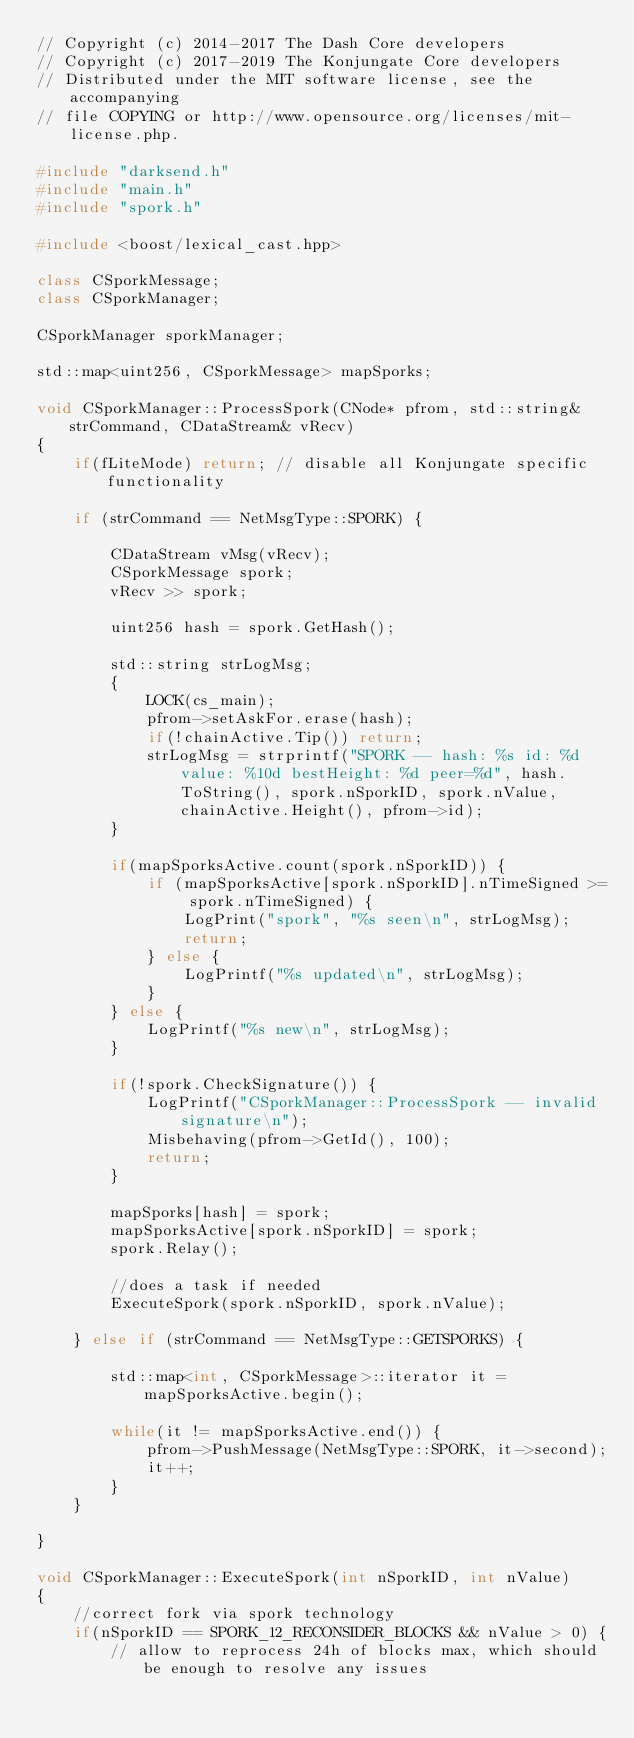Convert code to text. <code><loc_0><loc_0><loc_500><loc_500><_C++_>// Copyright (c) 2014-2017 The Dash Core developers
// Copyright (c) 2017-2019 The Konjungate Core developers
// Distributed under the MIT software license, see the accompanying
// file COPYING or http://www.opensource.org/licenses/mit-license.php.

#include "darksend.h"
#include "main.h"
#include "spork.h"

#include <boost/lexical_cast.hpp>

class CSporkMessage;
class CSporkManager;

CSporkManager sporkManager;

std::map<uint256, CSporkMessage> mapSporks;

void CSporkManager::ProcessSpork(CNode* pfrom, std::string& strCommand, CDataStream& vRecv)
{
    if(fLiteMode) return; // disable all Konjungate specific functionality

    if (strCommand == NetMsgType::SPORK) {

        CDataStream vMsg(vRecv);
        CSporkMessage spork;
        vRecv >> spork;

        uint256 hash = spork.GetHash();

        std::string strLogMsg;
        {
            LOCK(cs_main);
            pfrom->setAskFor.erase(hash);
            if(!chainActive.Tip()) return;
            strLogMsg = strprintf("SPORK -- hash: %s id: %d value: %10d bestHeight: %d peer=%d", hash.ToString(), spork.nSporkID, spork.nValue, chainActive.Height(), pfrom->id);
        }

        if(mapSporksActive.count(spork.nSporkID)) {
            if (mapSporksActive[spork.nSporkID].nTimeSigned >= spork.nTimeSigned) {
                LogPrint("spork", "%s seen\n", strLogMsg);
                return;
            } else {
                LogPrintf("%s updated\n", strLogMsg);
            }
        } else {
            LogPrintf("%s new\n", strLogMsg);
        }

        if(!spork.CheckSignature()) {
            LogPrintf("CSporkManager::ProcessSpork -- invalid signature\n");
            Misbehaving(pfrom->GetId(), 100);
            return;
        }

        mapSporks[hash] = spork;
        mapSporksActive[spork.nSporkID] = spork;
        spork.Relay();

        //does a task if needed
        ExecuteSpork(spork.nSporkID, spork.nValue);

    } else if (strCommand == NetMsgType::GETSPORKS) {

        std::map<int, CSporkMessage>::iterator it = mapSporksActive.begin();

        while(it != mapSporksActive.end()) {
            pfrom->PushMessage(NetMsgType::SPORK, it->second);
            it++;
        }
    }

}

void CSporkManager::ExecuteSpork(int nSporkID, int nValue)
{
    //correct fork via spork technology
    if(nSporkID == SPORK_12_RECONSIDER_BLOCKS && nValue > 0) {
        // allow to reprocess 24h of blocks max, which should be enough to resolve any issues</code> 